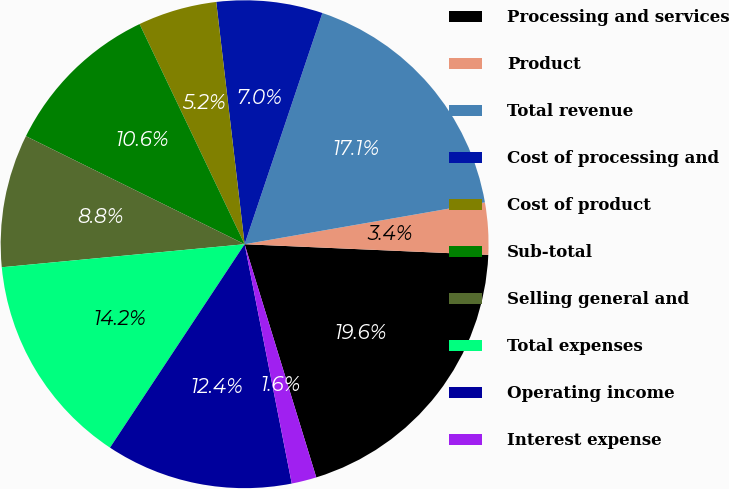<chart> <loc_0><loc_0><loc_500><loc_500><pie_chart><fcel>Processing and services<fcel>Product<fcel>Total revenue<fcel>Cost of processing and<fcel>Cost of product<fcel>Sub-total<fcel>Selling general and<fcel>Total expenses<fcel>Operating income<fcel>Interest expense<nl><fcel>19.56%<fcel>3.44%<fcel>17.09%<fcel>7.02%<fcel>5.23%<fcel>10.61%<fcel>8.81%<fcel>14.19%<fcel>12.4%<fcel>1.65%<nl></chart> 